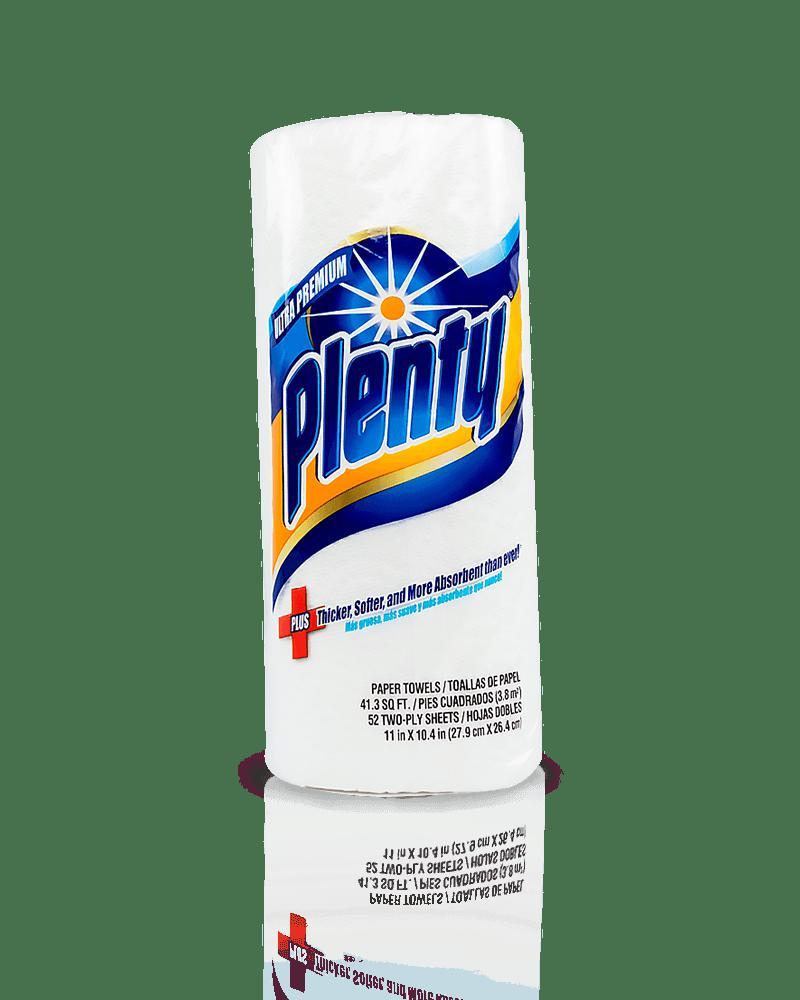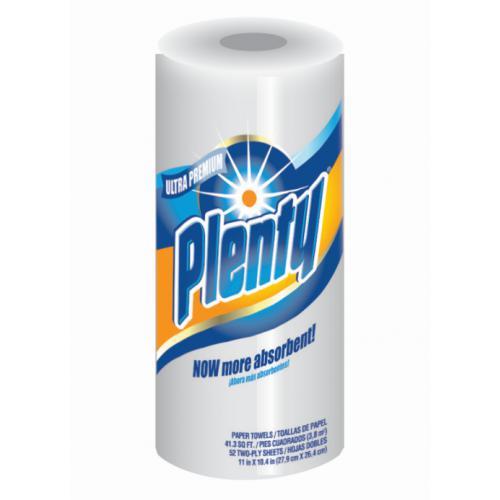The first image is the image on the left, the second image is the image on the right. Evaluate the accuracy of this statement regarding the images: "The package of paper towel in the image on the left contains more than 6 rolls.". Is it true? Answer yes or no. No. The first image is the image on the left, the second image is the image on the right. Assess this claim about the two images: "Right and left images show paper towel packs with blue and orange colors on the packaging, all packs feature a sunburst, and at least one features a red plus-sign.". Correct or not? Answer yes or no. Yes. 